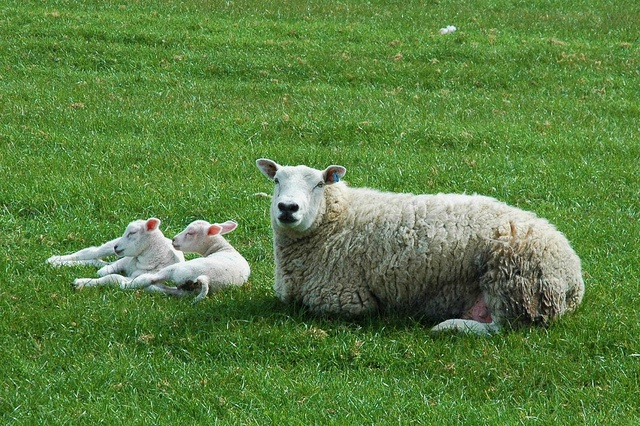Describe the objects in this image and their specific colors. I can see sheep in green, gray, black, darkgray, and lightgray tones, sheep in green, lightgray, darkgray, gray, and darkgreen tones, and sheep in green, darkgray, lightgray, and gray tones in this image. 